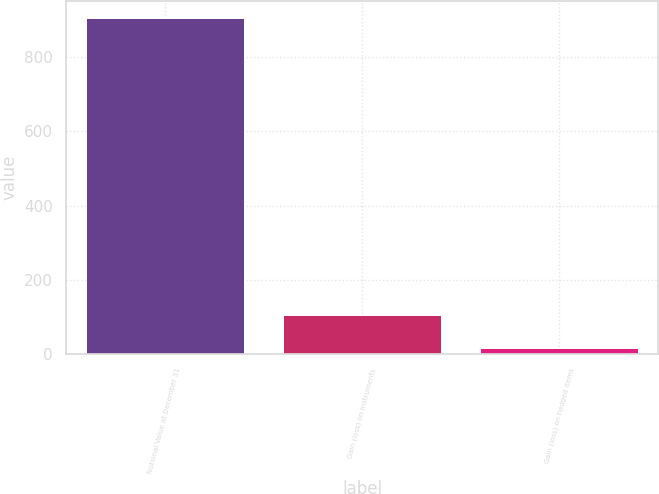Convert chart. <chart><loc_0><loc_0><loc_500><loc_500><bar_chart><fcel>Notional Value at December 31<fcel>Gain (loss) on instruments<fcel>Gain (loss) on hedged items<nl><fcel>905<fcel>104.9<fcel>16<nl></chart> 